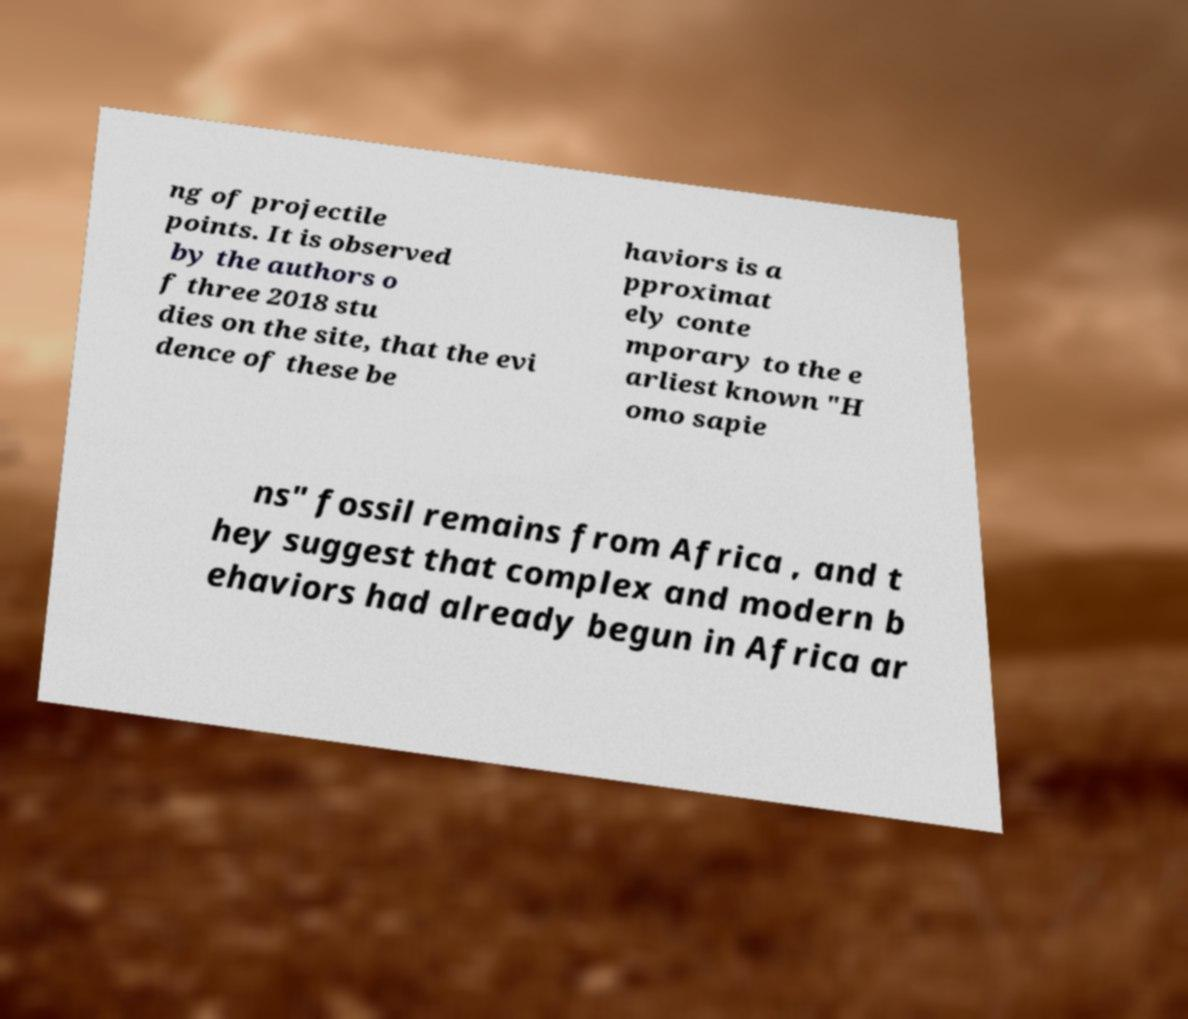Can you read and provide the text displayed in the image?This photo seems to have some interesting text. Can you extract and type it out for me? ng of projectile points. It is observed by the authors o f three 2018 stu dies on the site, that the evi dence of these be haviors is a pproximat ely conte mporary to the e arliest known "H omo sapie ns" fossil remains from Africa , and t hey suggest that complex and modern b ehaviors had already begun in Africa ar 